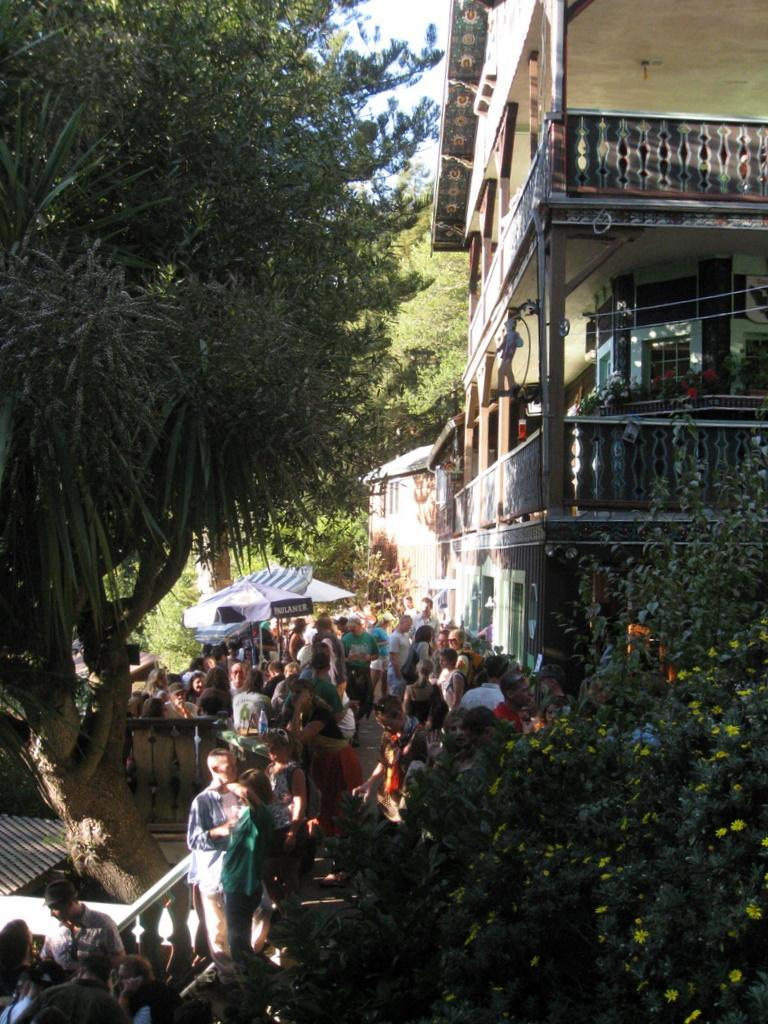Could you give a brief overview of what you see in this image? In this image we can see many people. On the left side there is a tree. On the right side there is a plant with flowers. Also there is a building with railings and pillars. In the back we can see tents. Also there are trees. 